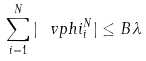<formula> <loc_0><loc_0><loc_500><loc_500>\sum _ { i = 1 } ^ { N } | \ v p h i _ { i } ^ { N } | \leq B \, \lambda</formula> 